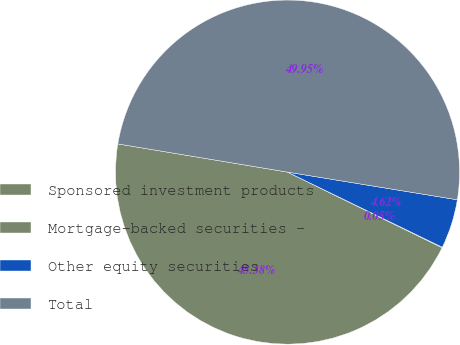Convert chart. <chart><loc_0><loc_0><loc_500><loc_500><pie_chart><fcel>Sponsored investment products<fcel>Mortgage-backed securities -<fcel>Other equity securities<fcel>Total<nl><fcel>45.38%<fcel>0.05%<fcel>4.62%<fcel>49.95%<nl></chart> 